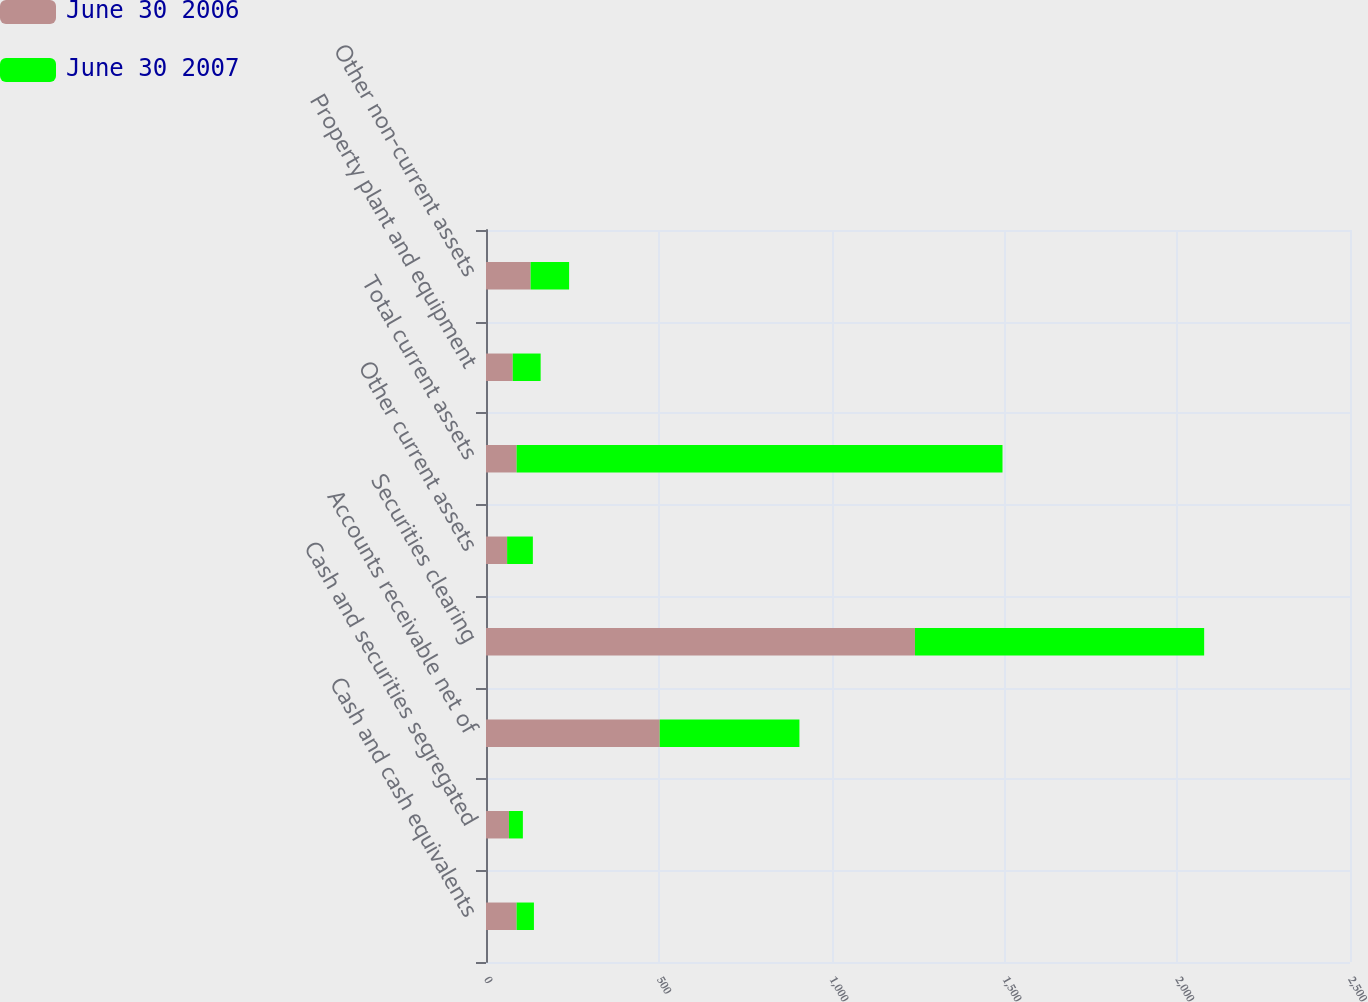Convert chart. <chart><loc_0><loc_0><loc_500><loc_500><stacked_bar_chart><ecel><fcel>Cash and cash equivalents<fcel>Cash and securities segregated<fcel>Accounts receivable net of<fcel>Securities clearing<fcel>Other current assets<fcel>Total current assets<fcel>Property plant and equipment<fcel>Other non-current assets<nl><fcel>June 30 2006<fcel>88.6<fcel>66.4<fcel>502.7<fcel>1241.2<fcel>61.1<fcel>88.6<fcel>77.4<fcel>129.2<nl><fcel>June 30 2007<fcel>50.1<fcel>40.3<fcel>404.2<fcel>836.8<fcel>74.5<fcel>1405.9<fcel>80.7<fcel>111.3<nl></chart> 